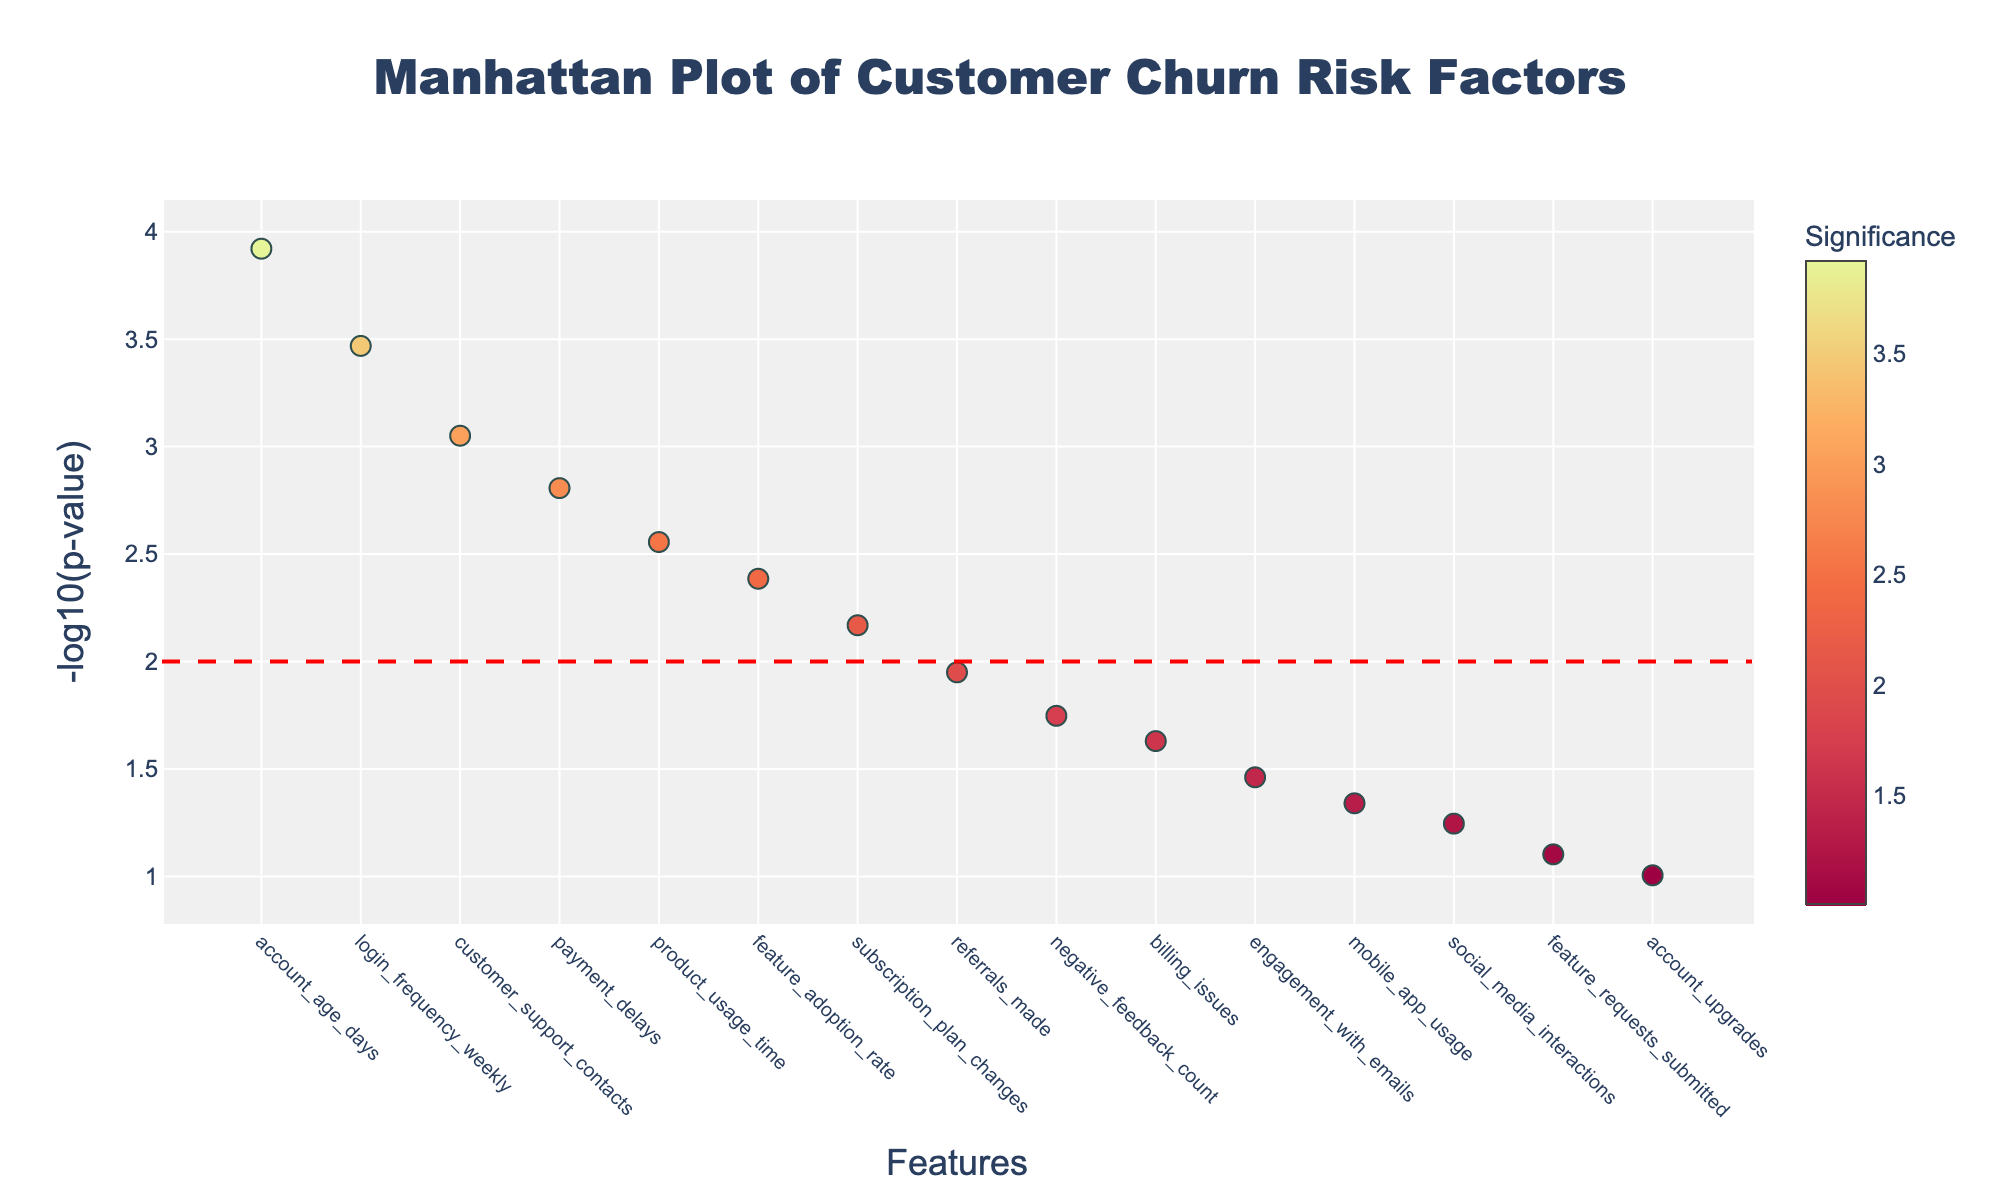What's the title of the plot? The title is prominently displayed at the top center of the figure. It reads "Manhattan Plot of Customer Churn Risk Factors".
Answer: Manhattan Plot of Customer Churn Risk Factors What is the axis label for the y-axis? The y-axis label is located to the left of the y-axis. It reads "-log10(p-value)", indicating that the y-axis is plotting the negative logarithm of the p-values.
Answer: -log10(p-value) Which feature has the smallest p-value? By looking at the leftmost data point on the plot, we can determine that the feature with the smallest p-value is "account_age_days".
Answer: account_age_days What is the significance of "login_frequency_weekly"? Hovering over the relevant data point or looking at its position, we see it has a color corresponding to its significance, which is 3.47.
Answer: 3.47 How many features have a -log10(p-value) greater than 2? By counting the data points above the red dashed horizontal line (which represents the threshold at -log10(p-value) = 2), we see there are six such features.
Answer: 6 Which feature shows the lowest significance value greater than 2? Checking data points above the red line and comparing their significance values, "feature_adoption_rate" has a significance value of 2.39, which is the lowest among those greater than 2.
Answer: feature_adoption_rate What are the features with negative feedback count and billing issues p-values? From the plot, the points associated with "negative_feedback_count" and "billing_issues" have p-values. Their respective positions help us identify that "negative_feedback_count" has a p-value represented by a higher y-axis value (1.75) than "billing_issues" (1.63).
Answer: 1.75 (negative_feedback_count), 1.63 (billing_issues) Compare the significance of "product_usage_time" and "payment_delays". Which is higher? Checking the significance color and height of points for "product_usage_time" and "payment_delays", "payment_delays" has a slightly higher significance value of 2.81 compared to 2.56 for "product_usage_time".
Answer: payment_delays What is the total number of features plotted? Reviewing the x-axis, it labels 15 distinct features, which corresponds to 15 data points in the plot.
Answer: 15 What is the feature with the highest -log10(p-value) after crossing 2? Looking at the tallest points above the red significance threshold line, "account_age_days" has the highest -log10(p-value) at 3.92.
Answer: account_age_days 